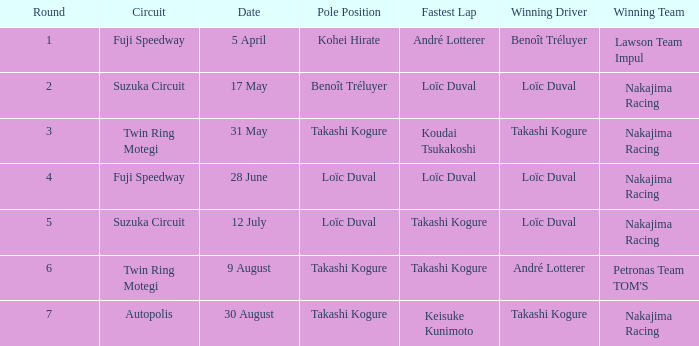How many drivers drove on Suzuka Circuit where Loïc Duval took pole position? 1.0. 